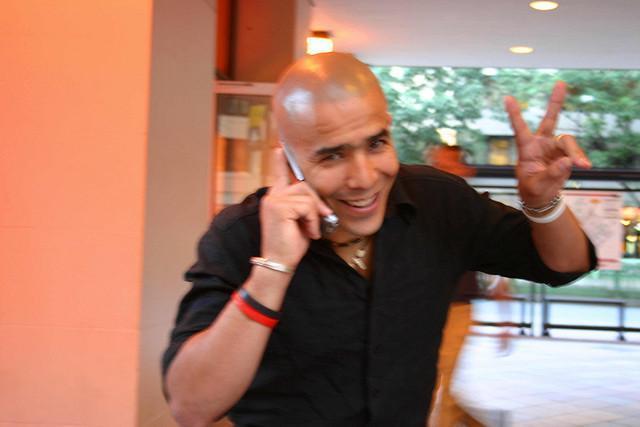How many fingers are up?
Give a very brief answer. 2. How many chairs are in this room?
Give a very brief answer. 0. 